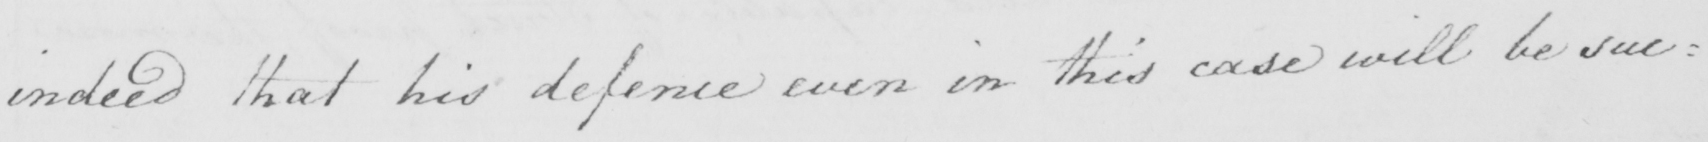Transcribe the text shown in this historical manuscript line. indeed that his defence even in this case will be suc= 